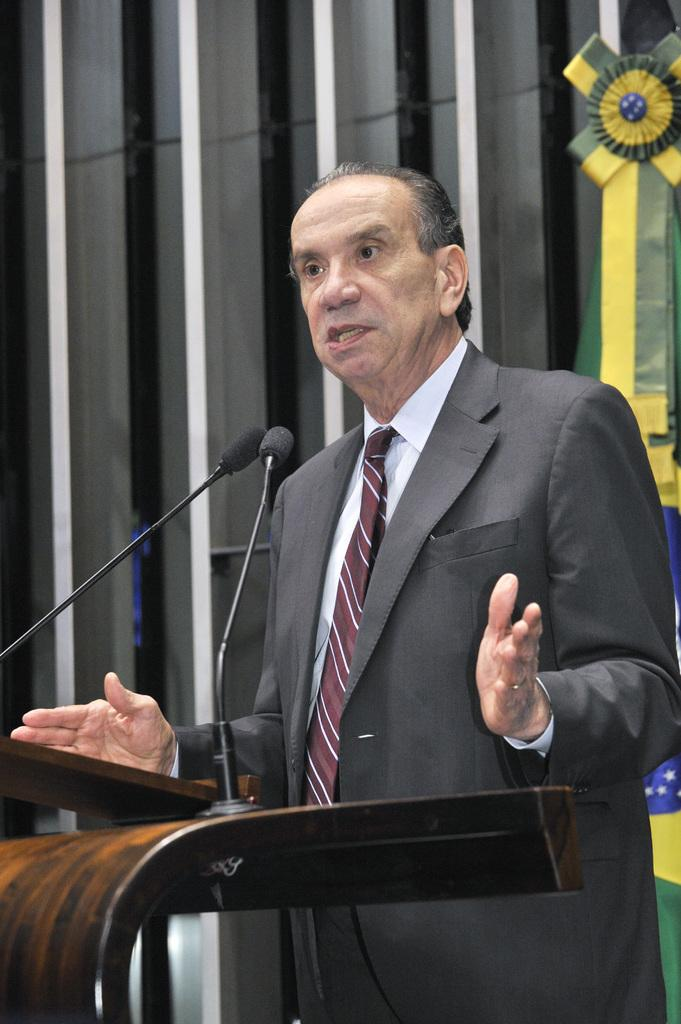Who is the main subject in the image? There is an old man in the image. What is the old man wearing? The old man is wearing a suit. Where is the old man standing in the image? The old man is standing near a wooden podium. What is the old man doing in the image? The old man is talking in front of microphones. What can be seen in the background of the image? There is a flag and a few objects visible in the background. Reasoning: Let' Let's think step by step in order to produce the conversation. We start by identifying the main subject in the image, which is the old man. Then, we describe his attire and location in the image. Next, we focus on the old man's actions, noting that he is talking in front of microphones. Finally, we mention the background elements, including the flag and other objects. Absurd Question/Answer: What type of cake is being served at the event in the image? There is no cake or event present in the image; it features an old man standing near a wooden podium and talking in front of microphones. Can you tell me how much blood is visible on the old man's suit? There is no blood visible on the old man's suit in the image. Who are the main subjects in the image? There is a group of people in the image. What are the people wearing? The people are wearing matching outfits. What are the people doing in the image? The people are holding hands. What can be seen in the background of the image? The background of the image is a beach, and there are waves visible. Reasoning: Let's think step by step in order to produce the conversation. We start by identifying the main subjects in the image, which are the group of people. Then, we describe their attire and actions. Next, we focus on the background elements, including the beach and waves. Each question is designed to elicit a specific detail about the image that is known from the provided facts. Absurd Question/Answer: What type of robot can be seen in the image? There is no robot present in the image; it features a group of people wearing matching outf 